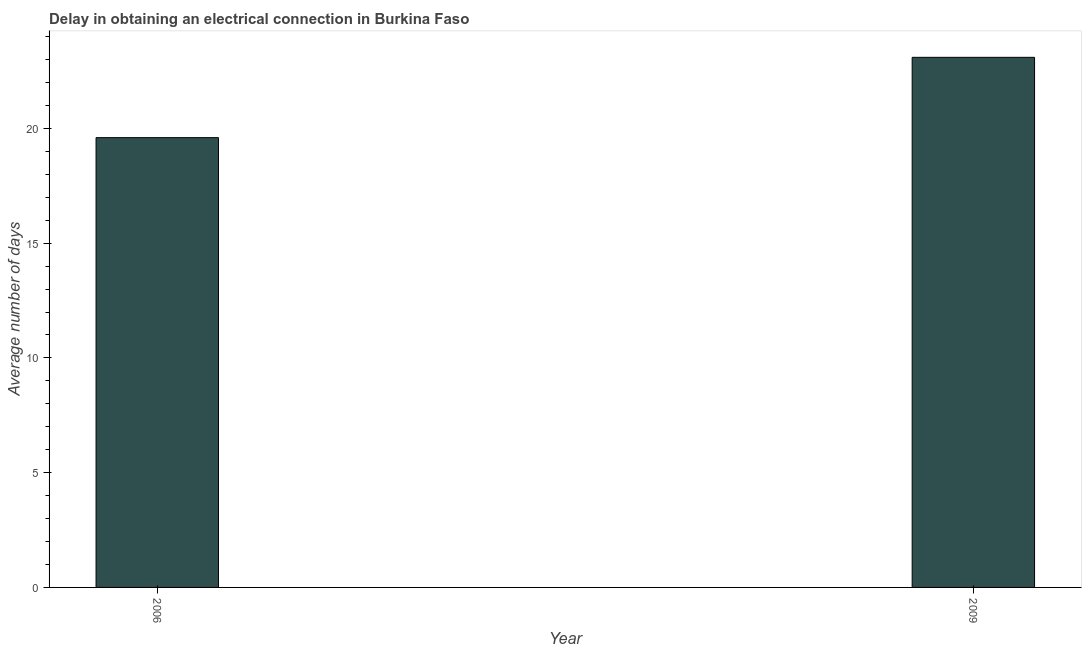Does the graph contain any zero values?
Make the answer very short. No. Does the graph contain grids?
Keep it short and to the point. No. What is the title of the graph?
Your response must be concise. Delay in obtaining an electrical connection in Burkina Faso. What is the label or title of the Y-axis?
Give a very brief answer. Average number of days. What is the dalay in electrical connection in 2009?
Offer a terse response. 23.1. Across all years, what is the maximum dalay in electrical connection?
Ensure brevity in your answer.  23.1. Across all years, what is the minimum dalay in electrical connection?
Provide a succinct answer. 19.6. In which year was the dalay in electrical connection maximum?
Give a very brief answer. 2009. What is the sum of the dalay in electrical connection?
Your answer should be compact. 42.7. What is the difference between the dalay in electrical connection in 2006 and 2009?
Offer a terse response. -3.5. What is the average dalay in electrical connection per year?
Provide a succinct answer. 21.35. What is the median dalay in electrical connection?
Provide a short and direct response. 21.35. What is the ratio of the dalay in electrical connection in 2006 to that in 2009?
Your response must be concise. 0.85. In how many years, is the dalay in electrical connection greater than the average dalay in electrical connection taken over all years?
Offer a terse response. 1. Are all the bars in the graph horizontal?
Give a very brief answer. No. How many years are there in the graph?
Ensure brevity in your answer.  2. What is the difference between two consecutive major ticks on the Y-axis?
Make the answer very short. 5. Are the values on the major ticks of Y-axis written in scientific E-notation?
Your answer should be compact. No. What is the Average number of days in 2006?
Your answer should be very brief. 19.6. What is the Average number of days of 2009?
Provide a short and direct response. 23.1. What is the ratio of the Average number of days in 2006 to that in 2009?
Provide a succinct answer. 0.85. 